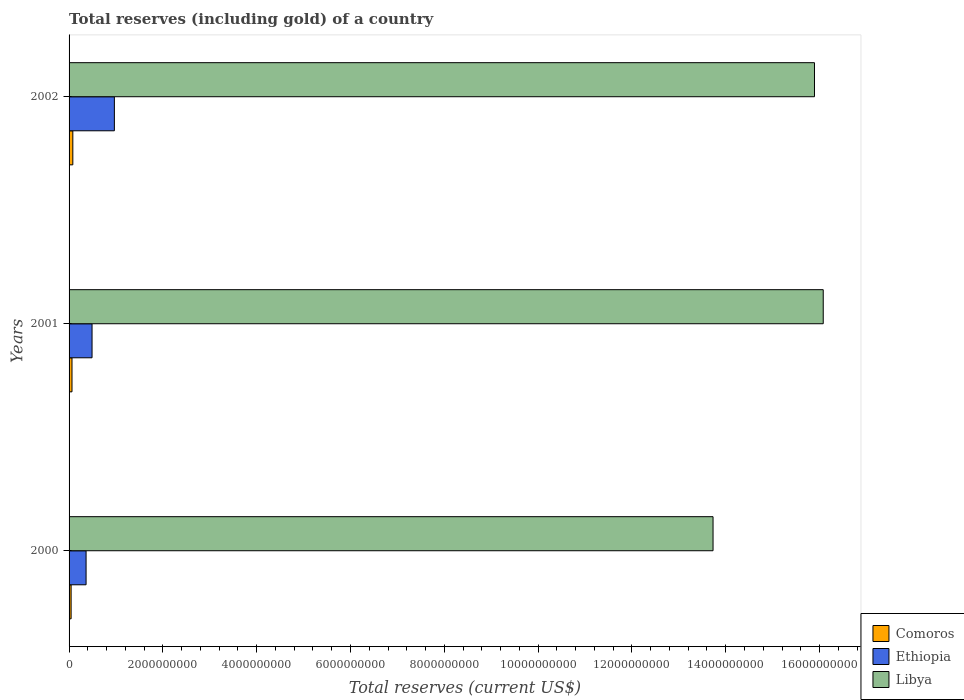How many different coloured bars are there?
Provide a short and direct response. 3. Are the number of bars on each tick of the Y-axis equal?
Make the answer very short. Yes. How many bars are there on the 3rd tick from the bottom?
Provide a short and direct response. 3. What is the total reserves (including gold) in Comoros in 2001?
Offer a very short reply. 6.25e+07. Across all years, what is the maximum total reserves (including gold) in Comoros?
Ensure brevity in your answer.  8.01e+07. Across all years, what is the minimum total reserves (including gold) in Ethiopia?
Provide a succinct answer. 3.63e+08. What is the total total reserves (including gold) in Ethiopia in the graph?
Provide a succinct answer. 1.82e+09. What is the difference between the total reserves (including gold) in Libya in 2000 and that in 2002?
Your answer should be compact. -2.16e+09. What is the difference between the total reserves (including gold) in Libya in 2000 and the total reserves (including gold) in Ethiopia in 2001?
Offer a terse response. 1.32e+1. What is the average total reserves (including gold) in Comoros per year?
Offer a very short reply. 6.20e+07. In the year 2000, what is the difference between the total reserves (including gold) in Libya and total reserves (including gold) in Comoros?
Provide a succinct answer. 1.37e+1. In how many years, is the total reserves (including gold) in Libya greater than 5200000000 US$?
Provide a succinct answer. 3. What is the ratio of the total reserves (including gold) in Libya in 2000 to that in 2001?
Make the answer very short. 0.85. Is the total reserves (including gold) in Comoros in 2000 less than that in 2001?
Offer a very short reply. Yes. Is the difference between the total reserves (including gold) in Libya in 2000 and 2002 greater than the difference between the total reserves (including gold) in Comoros in 2000 and 2002?
Your answer should be very brief. No. What is the difference between the highest and the second highest total reserves (including gold) in Ethiopia?
Offer a terse response. 4.76e+08. What is the difference between the highest and the lowest total reserves (including gold) in Libya?
Give a very brief answer. 2.35e+09. In how many years, is the total reserves (including gold) in Comoros greater than the average total reserves (including gold) in Comoros taken over all years?
Your response must be concise. 2. What does the 1st bar from the top in 2001 represents?
Offer a very short reply. Libya. What does the 2nd bar from the bottom in 2002 represents?
Offer a very short reply. Ethiopia. Is it the case that in every year, the sum of the total reserves (including gold) in Libya and total reserves (including gold) in Ethiopia is greater than the total reserves (including gold) in Comoros?
Provide a succinct answer. Yes. Does the graph contain any zero values?
Your answer should be very brief. No. Does the graph contain grids?
Provide a short and direct response. No. Where does the legend appear in the graph?
Give a very brief answer. Bottom right. How are the legend labels stacked?
Offer a terse response. Vertical. What is the title of the graph?
Make the answer very short. Total reserves (including gold) of a country. What is the label or title of the X-axis?
Provide a succinct answer. Total reserves (current US$). What is the label or title of the Y-axis?
Give a very brief answer. Years. What is the Total reserves (current US$) of Comoros in 2000?
Provide a succinct answer. 4.34e+07. What is the Total reserves (current US$) of Ethiopia in 2000?
Your answer should be very brief. 3.63e+08. What is the Total reserves (current US$) of Libya in 2000?
Your answer should be compact. 1.37e+1. What is the Total reserves (current US$) in Comoros in 2001?
Keep it short and to the point. 6.25e+07. What is the Total reserves (current US$) of Ethiopia in 2001?
Offer a terse response. 4.90e+08. What is the Total reserves (current US$) in Libya in 2001?
Your answer should be very brief. 1.61e+1. What is the Total reserves (current US$) of Comoros in 2002?
Ensure brevity in your answer.  8.01e+07. What is the Total reserves (current US$) of Ethiopia in 2002?
Your answer should be very brief. 9.66e+08. What is the Total reserves (current US$) in Libya in 2002?
Your answer should be very brief. 1.59e+1. Across all years, what is the maximum Total reserves (current US$) of Comoros?
Offer a terse response. 8.01e+07. Across all years, what is the maximum Total reserves (current US$) in Ethiopia?
Your answer should be very brief. 9.66e+08. Across all years, what is the maximum Total reserves (current US$) of Libya?
Make the answer very short. 1.61e+1. Across all years, what is the minimum Total reserves (current US$) in Comoros?
Your response must be concise. 4.34e+07. Across all years, what is the minimum Total reserves (current US$) in Ethiopia?
Offer a very short reply. 3.63e+08. Across all years, what is the minimum Total reserves (current US$) of Libya?
Make the answer very short. 1.37e+1. What is the total Total reserves (current US$) of Comoros in the graph?
Provide a succinct answer. 1.86e+08. What is the total Total reserves (current US$) of Ethiopia in the graph?
Keep it short and to the point. 1.82e+09. What is the total Total reserves (current US$) of Libya in the graph?
Provide a succinct answer. 4.57e+1. What is the difference between the Total reserves (current US$) in Comoros in 2000 and that in 2001?
Make the answer very short. -1.91e+07. What is the difference between the Total reserves (current US$) of Ethiopia in 2000 and that in 2001?
Offer a very short reply. -1.27e+08. What is the difference between the Total reserves (current US$) of Libya in 2000 and that in 2001?
Give a very brief answer. -2.35e+09. What is the difference between the Total reserves (current US$) in Comoros in 2000 and that in 2002?
Offer a very short reply. -3.68e+07. What is the difference between the Total reserves (current US$) of Ethiopia in 2000 and that in 2002?
Ensure brevity in your answer.  -6.03e+08. What is the difference between the Total reserves (current US$) in Libya in 2000 and that in 2002?
Keep it short and to the point. -2.16e+09. What is the difference between the Total reserves (current US$) in Comoros in 2001 and that in 2002?
Keep it short and to the point. -1.77e+07. What is the difference between the Total reserves (current US$) of Ethiopia in 2001 and that in 2002?
Your answer should be very brief. -4.76e+08. What is the difference between the Total reserves (current US$) in Libya in 2001 and that in 2002?
Your answer should be very brief. 1.87e+08. What is the difference between the Total reserves (current US$) in Comoros in 2000 and the Total reserves (current US$) in Ethiopia in 2001?
Your answer should be compact. -4.47e+08. What is the difference between the Total reserves (current US$) of Comoros in 2000 and the Total reserves (current US$) of Libya in 2001?
Your response must be concise. -1.60e+1. What is the difference between the Total reserves (current US$) in Ethiopia in 2000 and the Total reserves (current US$) in Libya in 2001?
Keep it short and to the point. -1.57e+1. What is the difference between the Total reserves (current US$) in Comoros in 2000 and the Total reserves (current US$) in Ethiopia in 2002?
Provide a succinct answer. -9.23e+08. What is the difference between the Total reserves (current US$) in Comoros in 2000 and the Total reserves (current US$) in Libya in 2002?
Ensure brevity in your answer.  -1.58e+1. What is the difference between the Total reserves (current US$) of Ethiopia in 2000 and the Total reserves (current US$) of Libya in 2002?
Offer a very short reply. -1.55e+1. What is the difference between the Total reserves (current US$) in Comoros in 2001 and the Total reserves (current US$) in Ethiopia in 2002?
Give a very brief answer. -9.03e+08. What is the difference between the Total reserves (current US$) of Comoros in 2001 and the Total reserves (current US$) of Libya in 2002?
Keep it short and to the point. -1.58e+1. What is the difference between the Total reserves (current US$) of Ethiopia in 2001 and the Total reserves (current US$) of Libya in 2002?
Your answer should be compact. -1.54e+1. What is the average Total reserves (current US$) of Comoros per year?
Your response must be concise. 6.20e+07. What is the average Total reserves (current US$) in Ethiopia per year?
Give a very brief answer. 6.06e+08. What is the average Total reserves (current US$) of Libya per year?
Your response must be concise. 1.52e+1. In the year 2000, what is the difference between the Total reserves (current US$) of Comoros and Total reserves (current US$) of Ethiopia?
Make the answer very short. -3.19e+08. In the year 2000, what is the difference between the Total reserves (current US$) of Comoros and Total reserves (current US$) of Libya?
Offer a very short reply. -1.37e+1. In the year 2000, what is the difference between the Total reserves (current US$) of Ethiopia and Total reserves (current US$) of Libya?
Give a very brief answer. -1.34e+1. In the year 2001, what is the difference between the Total reserves (current US$) in Comoros and Total reserves (current US$) in Ethiopia?
Give a very brief answer. -4.27e+08. In the year 2001, what is the difference between the Total reserves (current US$) of Comoros and Total reserves (current US$) of Libya?
Give a very brief answer. -1.60e+1. In the year 2001, what is the difference between the Total reserves (current US$) of Ethiopia and Total reserves (current US$) of Libya?
Offer a very short reply. -1.56e+1. In the year 2002, what is the difference between the Total reserves (current US$) in Comoros and Total reserves (current US$) in Ethiopia?
Your response must be concise. -8.86e+08. In the year 2002, what is the difference between the Total reserves (current US$) of Comoros and Total reserves (current US$) of Libya?
Your answer should be compact. -1.58e+1. In the year 2002, what is the difference between the Total reserves (current US$) in Ethiopia and Total reserves (current US$) in Libya?
Make the answer very short. -1.49e+1. What is the ratio of the Total reserves (current US$) in Comoros in 2000 to that in 2001?
Provide a short and direct response. 0.69. What is the ratio of the Total reserves (current US$) in Ethiopia in 2000 to that in 2001?
Your answer should be compact. 0.74. What is the ratio of the Total reserves (current US$) of Libya in 2000 to that in 2001?
Provide a short and direct response. 0.85. What is the ratio of the Total reserves (current US$) of Comoros in 2000 to that in 2002?
Give a very brief answer. 0.54. What is the ratio of the Total reserves (current US$) in Ethiopia in 2000 to that in 2002?
Provide a short and direct response. 0.38. What is the ratio of the Total reserves (current US$) of Libya in 2000 to that in 2002?
Your answer should be very brief. 0.86. What is the ratio of the Total reserves (current US$) of Comoros in 2001 to that in 2002?
Offer a very short reply. 0.78. What is the ratio of the Total reserves (current US$) of Ethiopia in 2001 to that in 2002?
Your response must be concise. 0.51. What is the ratio of the Total reserves (current US$) in Libya in 2001 to that in 2002?
Keep it short and to the point. 1.01. What is the difference between the highest and the second highest Total reserves (current US$) in Comoros?
Ensure brevity in your answer.  1.77e+07. What is the difference between the highest and the second highest Total reserves (current US$) in Ethiopia?
Your answer should be very brief. 4.76e+08. What is the difference between the highest and the second highest Total reserves (current US$) of Libya?
Your answer should be compact. 1.87e+08. What is the difference between the highest and the lowest Total reserves (current US$) in Comoros?
Your answer should be very brief. 3.68e+07. What is the difference between the highest and the lowest Total reserves (current US$) of Ethiopia?
Your answer should be compact. 6.03e+08. What is the difference between the highest and the lowest Total reserves (current US$) of Libya?
Keep it short and to the point. 2.35e+09. 